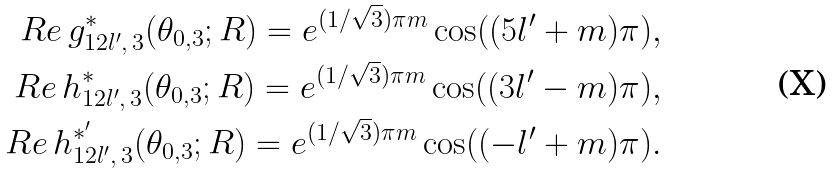Convert formula to latex. <formula><loc_0><loc_0><loc_500><loc_500>R e \, g _ { 1 2 l ^ { \prime } , \, 3 } ^ { * } ( \theta _ { 0 , 3 } ; R ) = e ^ { ( 1 / \sqrt { 3 } ) \pi m } \cos ( ( 5 l ^ { \prime } + m ) \pi ) , \\ R e \, h _ { 1 2 l ^ { \prime } , \, 3 } ^ { * } ( \theta _ { 0 , 3 } ; R ) = e ^ { ( 1 / \sqrt { 3 } ) \pi m } \cos ( ( 3 l ^ { \prime } - m ) \pi ) , \\ R e \, h _ { 1 2 l ^ { \prime } , \, 3 } ^ { * ^ { \prime } } ( \theta _ { 0 , 3 } ; R ) = e ^ { ( 1 / \sqrt { 3 } ) \pi m } \cos ( ( - l ^ { \prime } + m ) \pi ) .</formula> 